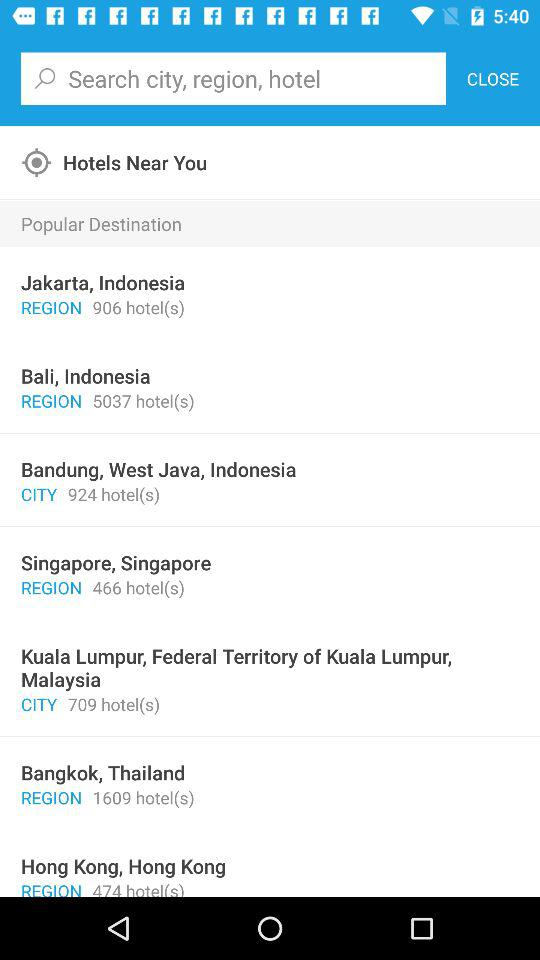In what country are there 1609 hotels present? The country is Thailand. 